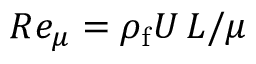Convert formula to latex. <formula><loc_0><loc_0><loc_500><loc_500>R e _ { \mu } = \rho _ { f } U \, L / \mu</formula> 